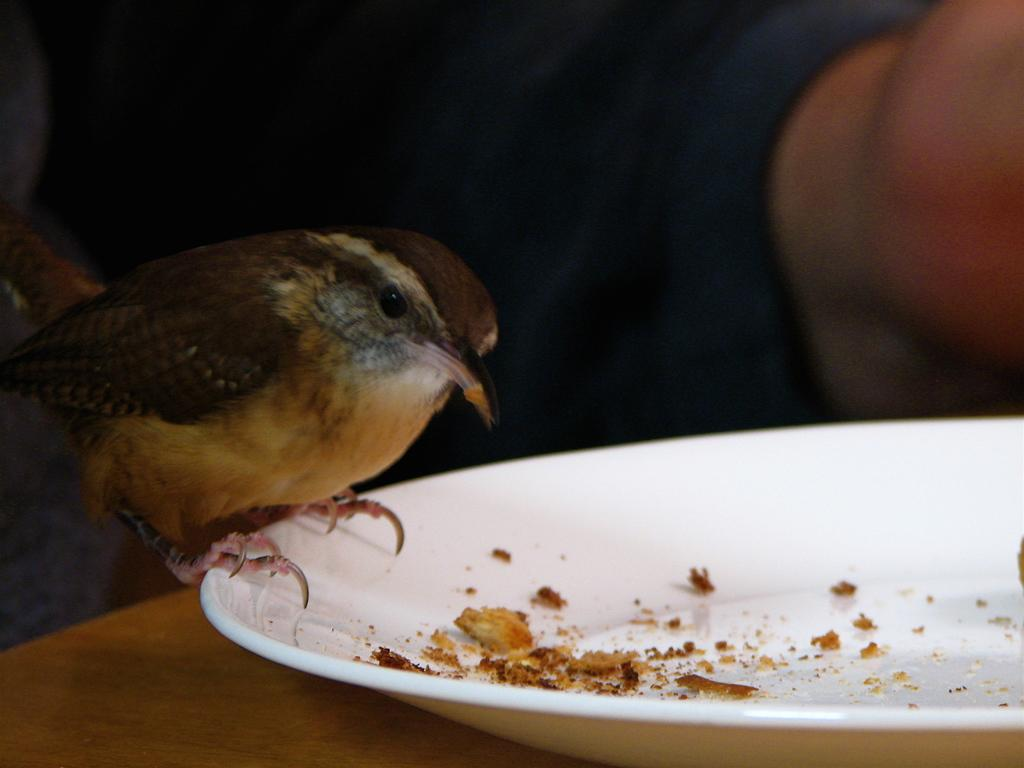What is on the plate in the image? There is a bird on a plate in the image. Can you describe the bird's appearance? The bird is black and brown in color. What else is on the plate besides the bird? There is food in the plate. Where is the plate located? The plate is on a table. Who else is present in the image? There is a human visible in the image. Can you tell me how many hens are visible in the image? There are no hens visible in the image; it features a bird on a plate. What type of place is shown in the image? The image does not depict a specific place; it focuses on the bird, plate, and food. 